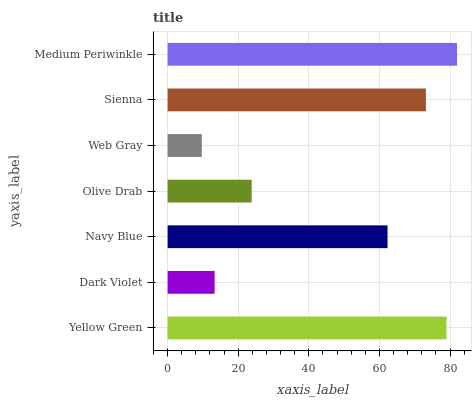Is Web Gray the minimum?
Answer yes or no. Yes. Is Medium Periwinkle the maximum?
Answer yes or no. Yes. Is Dark Violet the minimum?
Answer yes or no. No. Is Dark Violet the maximum?
Answer yes or no. No. Is Yellow Green greater than Dark Violet?
Answer yes or no. Yes. Is Dark Violet less than Yellow Green?
Answer yes or no. Yes. Is Dark Violet greater than Yellow Green?
Answer yes or no. No. Is Yellow Green less than Dark Violet?
Answer yes or no. No. Is Navy Blue the high median?
Answer yes or no. Yes. Is Navy Blue the low median?
Answer yes or no. Yes. Is Medium Periwinkle the high median?
Answer yes or no. No. Is Olive Drab the low median?
Answer yes or no. No. 